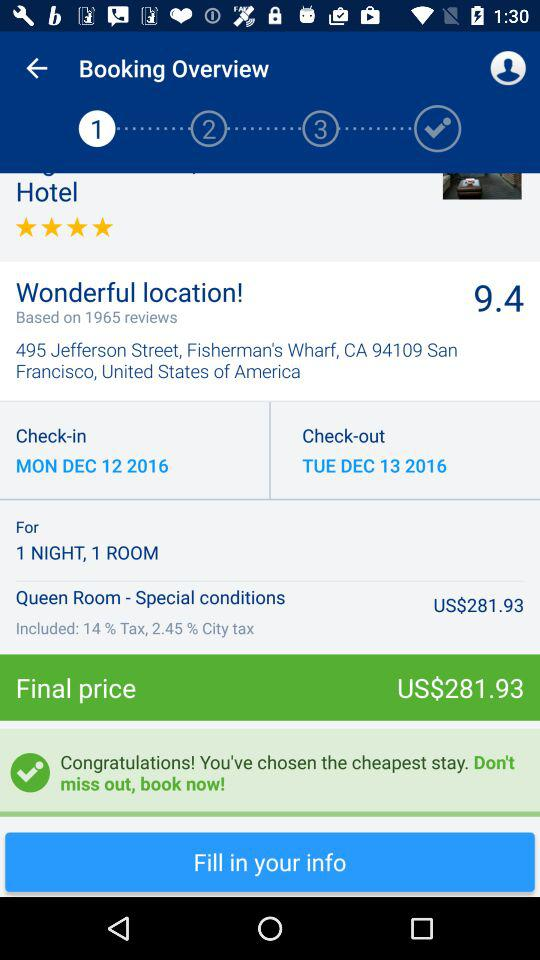What is the star rating for the hotel? The rating for the hotel is 4 stars. 